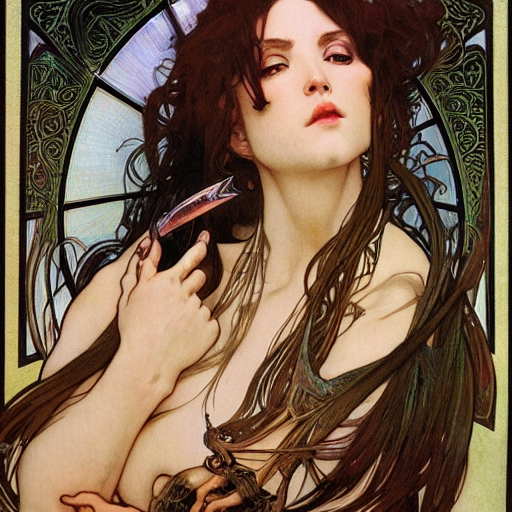What artistic style is represented in this image? The image reflects an art nouveau style, characterized by its curvilinear lines, natural forms, and ornamental details, creating an aesthetic that's both elegant and organic. Can you tell me more about the subject's appearance? Certainly. The subject has a fair complexion, with dark hair styled loosely around her shoulders, evoking a natural yet intense aesthetic. Her expression is pensive and alluring, with a gaze that seems to extend beyond the frame, inviting contemplation. 